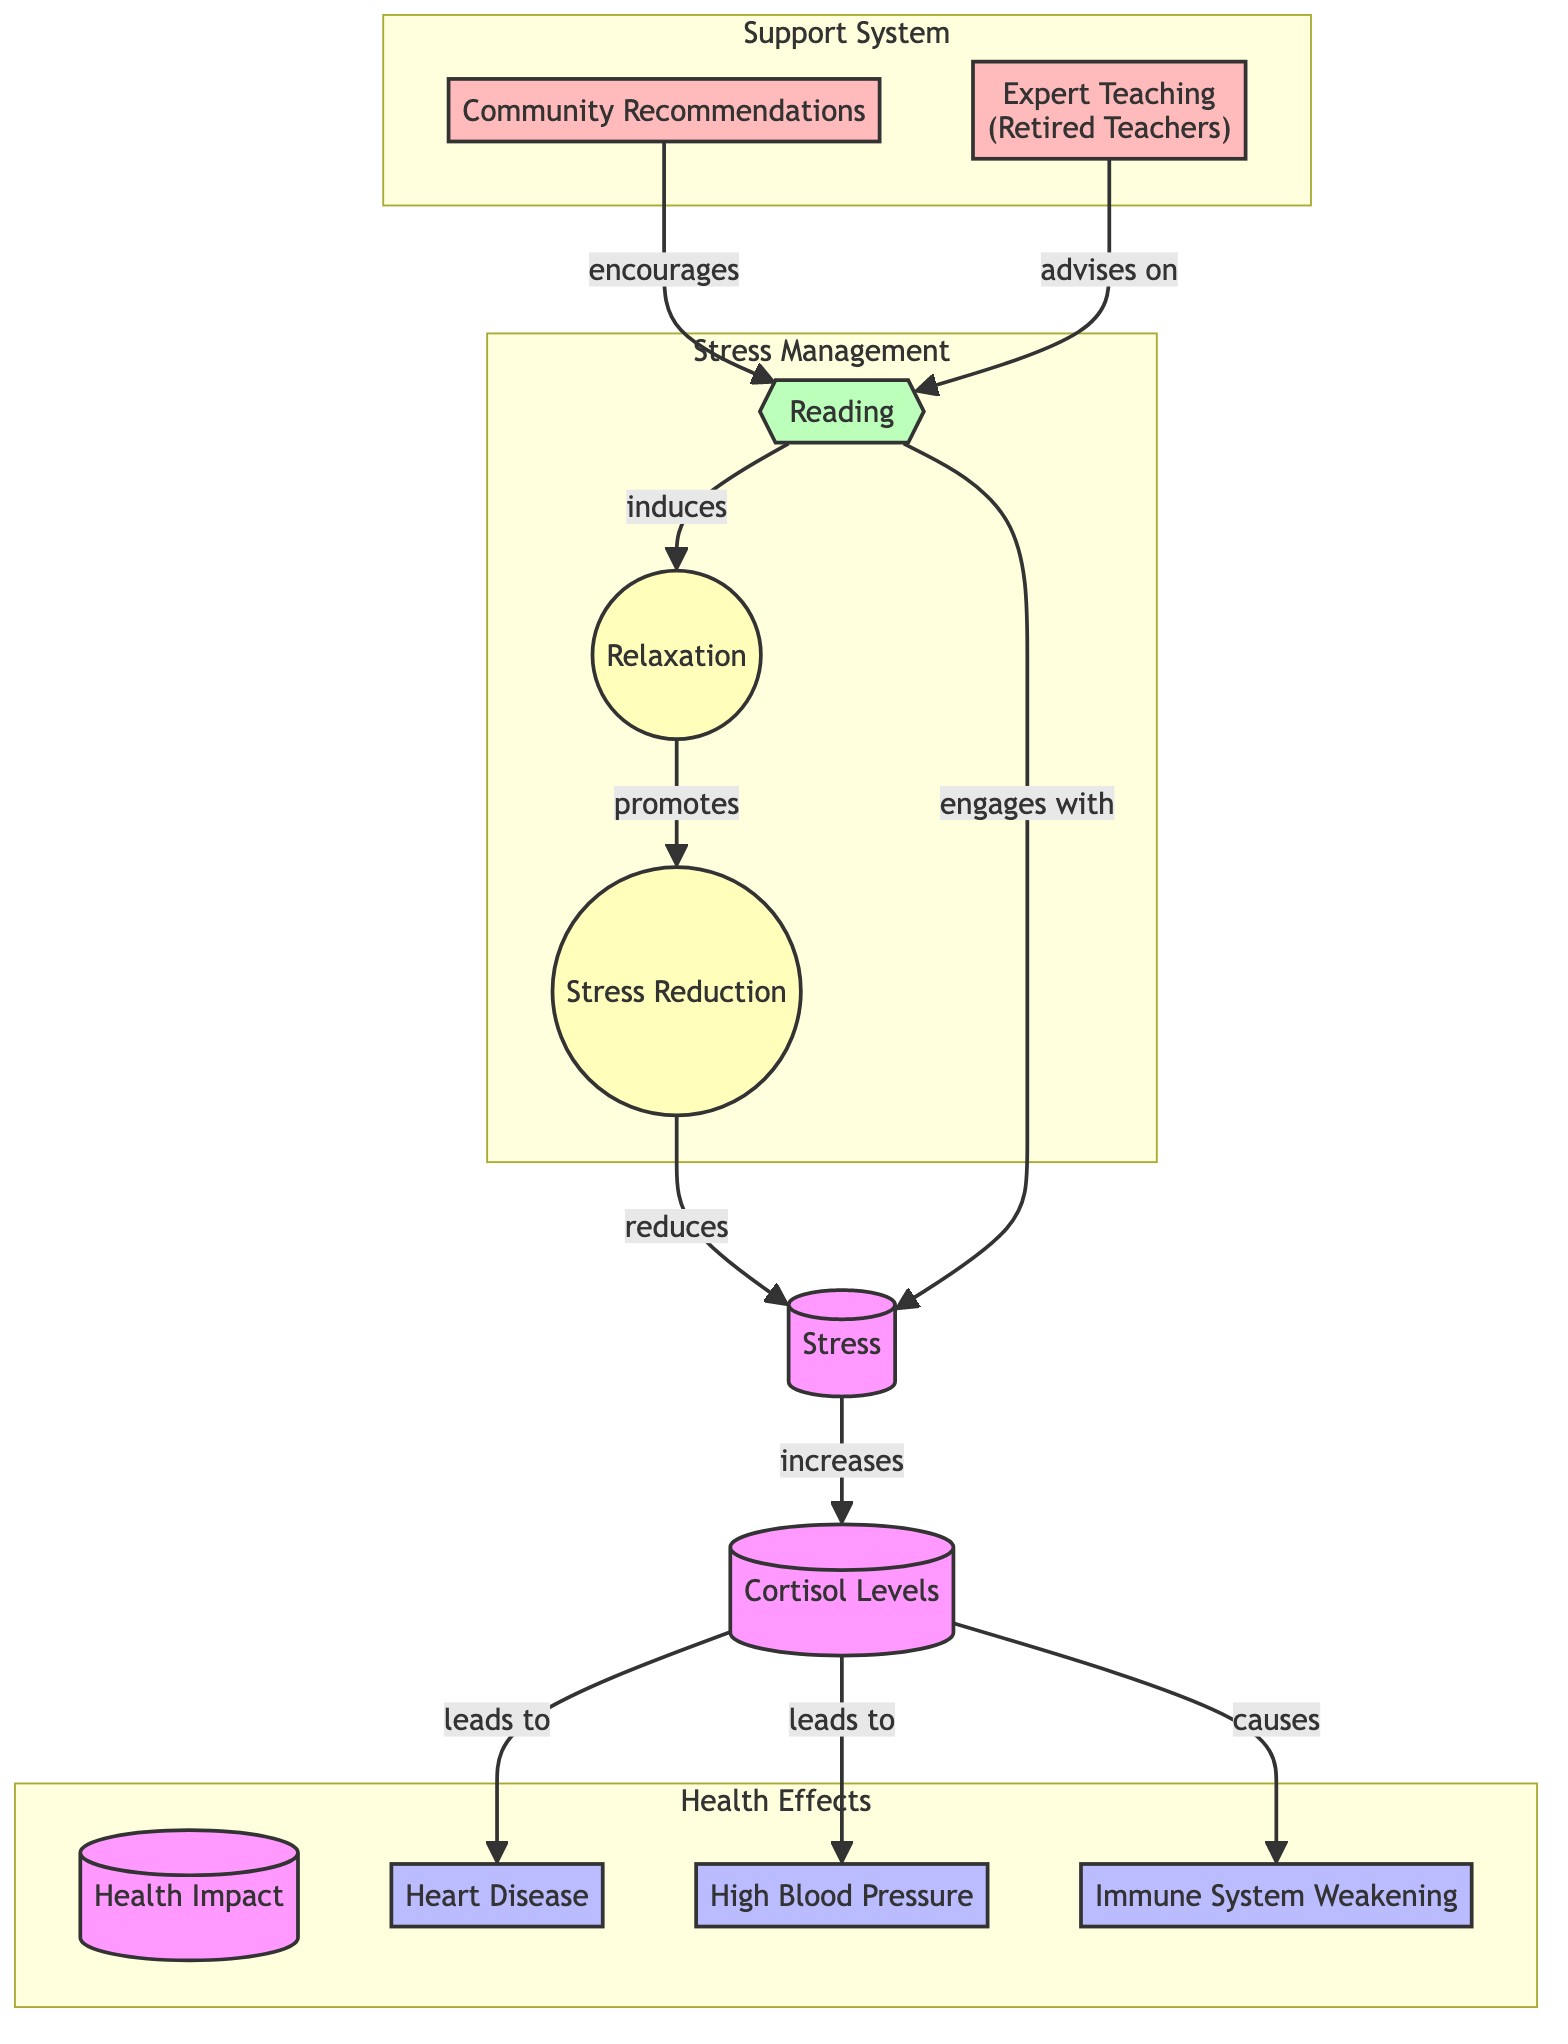What is the first node in the diagram? The first node is labeled "Stress," which is the starting point of the flow in the diagram.
Answer: Stress How many health impacts are listed in the diagram? There are three health impacts listed: Heart Disease, High Blood Pressure, and Immune System Weakening. This can be counted from the nodes connected to the "Health Impact" node.
Answer: 3 What does increased cortisol levels lead to? Increased cortisol levels lead to three conditions: Heart Disease, High Blood Pressure, and Immune System Weakening, as shown by the arrows indicating the flow from cortisol levels to these conditions.
Answer: Heart Disease, High Blood Pressure, Immune System Weakening What activity promotes relaxation in the diagram? The activity that promotes relaxation is "Reading," which is shown in the flow from the "Reading" node to the "Relaxation" node.
Answer: Reading Which node is indicated as a form of support for reading? The nodes "Community Recommendations" and "Expert Teaching (Retired Teachers)" provide support for reading, as they both connect to the "Reading" node.
Answer: Community Recommendations, Expert Teaching (Retired Teachers) How does reading impact stress levels according to the diagram? Reading induces relaxation, which promotes stress reduction, leading ultimately back to reducing stress. This flow illustrates the connection between reading and stress relief sequentially.
Answer: Reduces stress What role does engagement with reading have in stress levels? Engagement with reading is depicted as an activity that engages with stress, indicating that it can serve as a management mechanism for stress through immersion in reading.
Answer: Engages with stress What is the outcome of doing "Reading" as depicted in the diagram? Engaging in reading induces relaxation, promotes stress reduction, and ultimately leads to a reduction in stress, indicating its effective role as a stress-relief mechanism.
Answer: Stress Reduction What are the conditions caused by increased cortisol levels? Increased cortisol levels cause three conditions: Heart Disease, High Blood Pressure, and Immune System Weakening, as shown by the flow from cortisol levels to these specific health impacts.
Answer: Heart Disease, High Blood Pressure, Immune System Weakening 